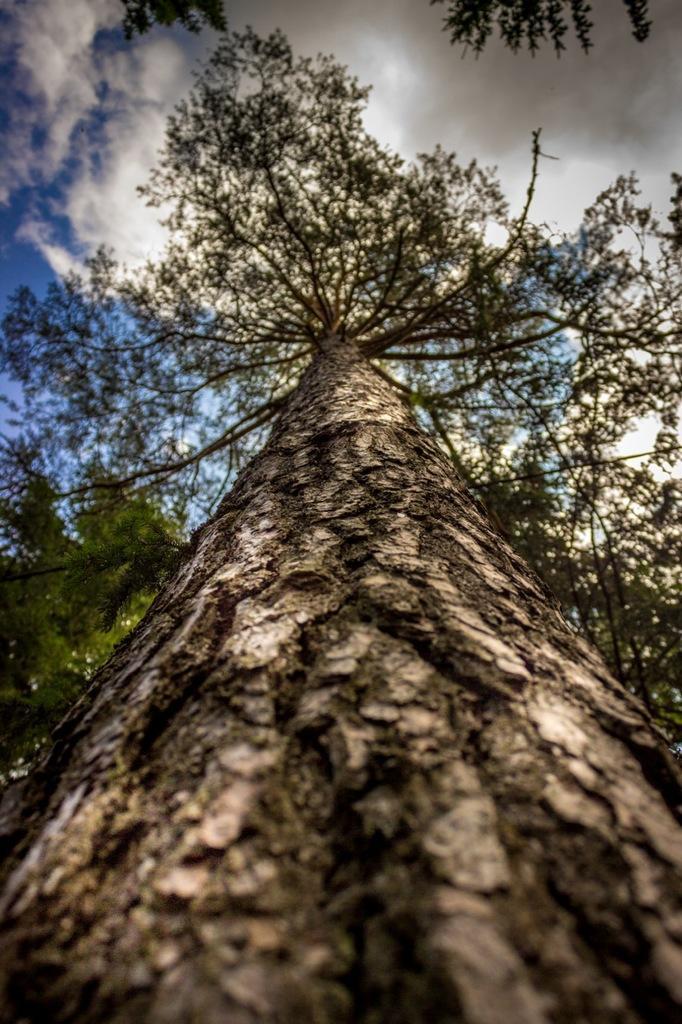Can you describe this image briefly? In the center of the image there is a tree. At the top of the image there are clouds and sky. 